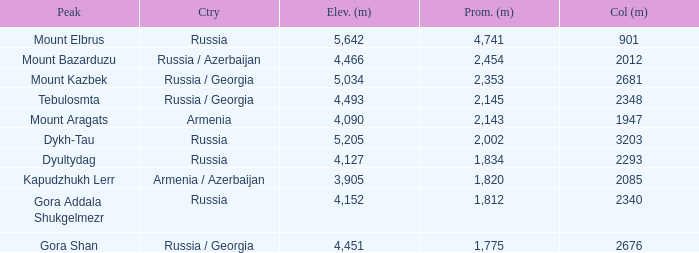What is the Col (m) of Peak Mount Aragats with an Elevation (m) larger than 3,905 and Prominence smaller than 2,143? None. 